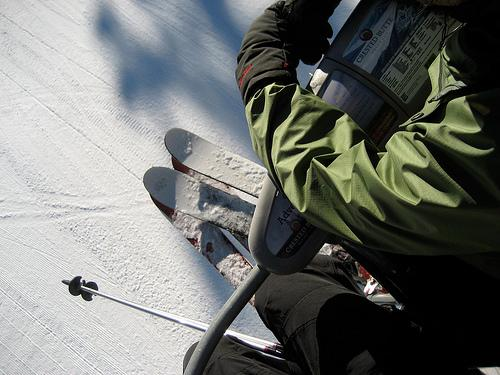Discuss the state of the skis and any associated elements within the image. The skis have snow on their tops and are touching the snow-covered ground, with shadows on them and ruts near them, and the person is wearing a ski pole with a black tip. Narrate the scenery and surroundings in which the person is situated. The person is on a snow-covered ground, wearing skis with snow on them, holding a ski pole over the snow, and standing near a ski lift with a white sticker on it. What is the person holding in their hand and what are its features? The person is holding a silver ski pole with a black tip, a spiky end, and two silver cylinders at the bottom, covered by a black glove with a red logo. Identify any shadows in the image and where they lie. There are shadows on the skis and the snow-covered ground, and the ski pole casts a shadow over the snow as well. What objects are found near the ski pole in the image? The ski pole tip, a ski lift bar, and the person's black glove with a red writing are found near the ski pole in the image. List all the objects related to snow in the image. White ski with bits of snow, snow on the ground, ruts in the snow, snow on the ski tops, white snow on ground, skis with snow, snow on the skis. Discuss the quality of the image based on clarity, visibility, and details provided. The image is of decent quality, providing visibility and details of the person, their attire, skis, ski pole, and the surrounding snow-covered environment. Can you describe the arm position of the person in the image? The person's arm is holding a ski pole, and their black glove-covered hand is partially visible, with left sleeve of their jacket shown in detail. Share any details about the person's glove and what it features. The person is wearing black gloves with a red logo, possibly a writing or a mark, on them, holding a ski pole with a black tip. Identify the color of the person's jacket and explain any prominent features on it. The person is wearing a green jacket with two black buttons on the shoulder area, a strap on the shoulder, and wrinkles around it. Did you notice the orange traffic cone behind the ski lift's bar? Locate it and measure its height. No, it's not mentioned in the image. Describe the interactions between the objects in the image. The skier is wearing skis, holding ski poles, and is near snow ruts near a ski lift, with shadow on the ground. Analyze the emotional sentiment of the image. The sentiment of the image is neutral. Find any unusual objects or anomalies in the image. There are no significant anomalies in the image. Assess the quality of the image. The image quality is clear and well-lit. Locate the person wearing the black glove with a red logo. X:227 Y:1 Width:109 Height:109 Identify and segregate different sections of the image. Skis and snow: X:137 Y:118 Width:172 Height:172; Skier's arm and jacket: X:244 Y:13 Width:253 Height:253; Snowmobile: X:212 Y:11 Width:285 Height:285 Are the skis on the ground covered with snow? Yes, the skis are covered with snow. What color is the jacket in the image? The jacket is green. Identify the objects present in the image. White ski with snow, ski poles, tips of skis, snow, ruts in snow, jacket wrinkles, skier's arm, shadow, ski pole tip, ski lift, silver cylinders at ski pole bottom, spiky tip, black glove, red writing on gloves, white sticker on snow lift, left sleeve of a jacket, black buttons on jacket shoulder, strap, snow on skis, white snow on ground, person wearing green jacket, person on a snowmobile, person wearing skis, ski pole with black tip, black gloves with red mark. Recognize the text written on the objects. Red writing on the person's glove. 